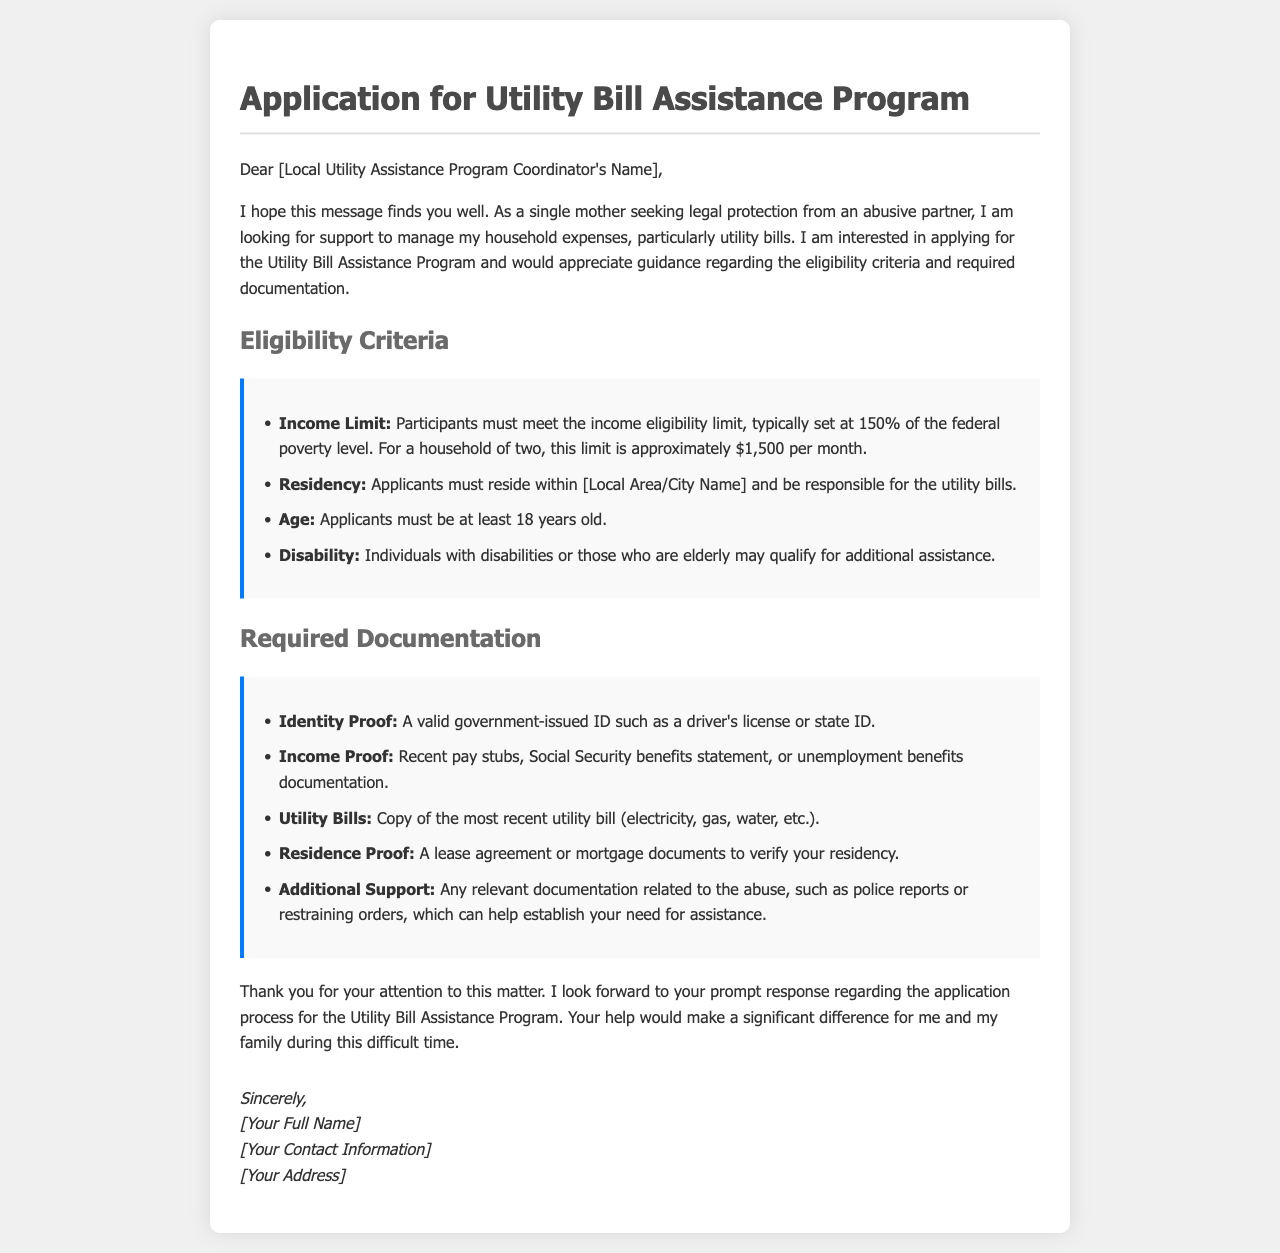What is the title of the document? The title is stated at the beginning of the document as "Application for Utility Bill Assistance Program."
Answer: Application for Utility Bill Assistance Program What is the maximum income limit for a household of two? The document specifies that the income limit is usually set at 150% of the federal poverty level, which is approximately $1,500 per month for a household of two.
Answer: $1,500 What is one type of proof required for identity? The document lists a valid government-issued ID, like a driver's license or state ID, as required identity proof.
Answer: government-issued ID What other documentation might be relevant to the application? The document mentions that any relevant documentation related to abuse, such as police reports or restraining orders, can help establish the need for assistance.
Answer: police reports or restraining orders What is the minimum age requirement for applicants? The document states that applicants must be at least 18 years old to be eligible for the program.
Answer: 18 years old What does the applicant seek assistance for? The document indicates that the applicant is seeking support to manage their household expenses, particularly utility bills.
Answer: utility bills In which location must applicants reside? The criteria specify that applicants must reside within the local area or city name mentioned in the specific program context.
Answer: [Local Area/City Name] What is the overall purpose of the email? The purpose of the email is to request guidance regarding the application process for the Utility Bill Assistance Program.
Answer: guidance regarding the application process 